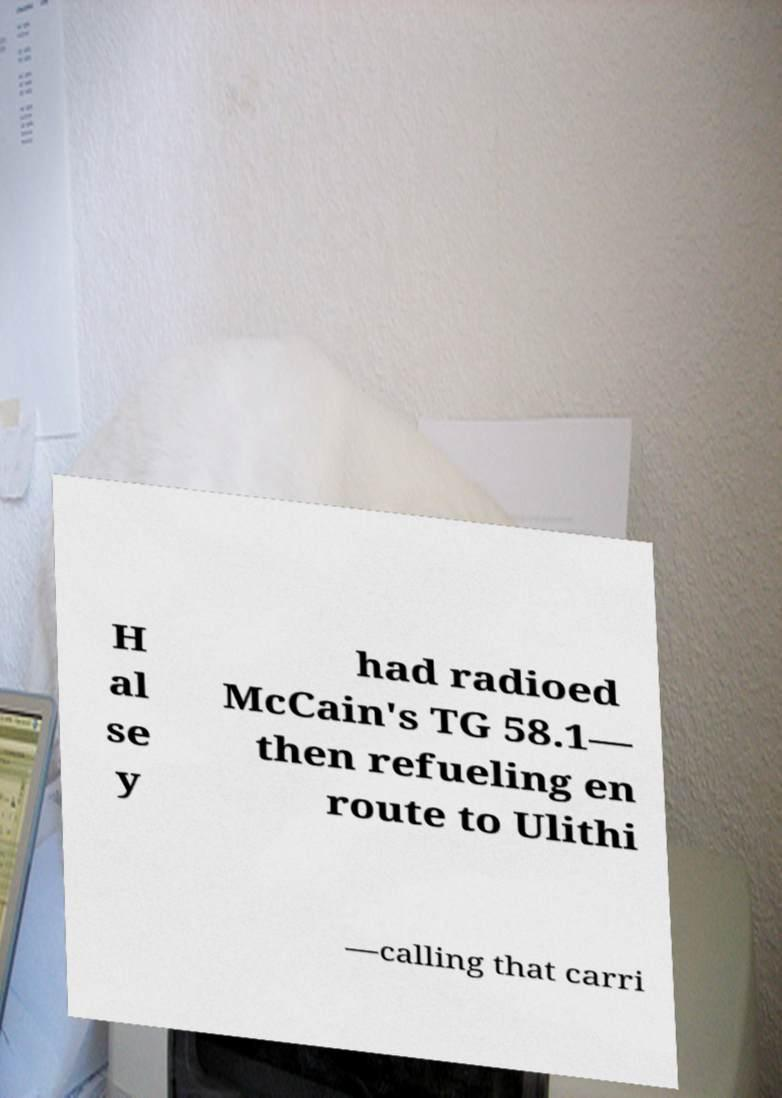Please identify and transcribe the text found in this image. H al se y had radioed McCain's TG 58.1— then refueling en route to Ulithi —calling that carri 